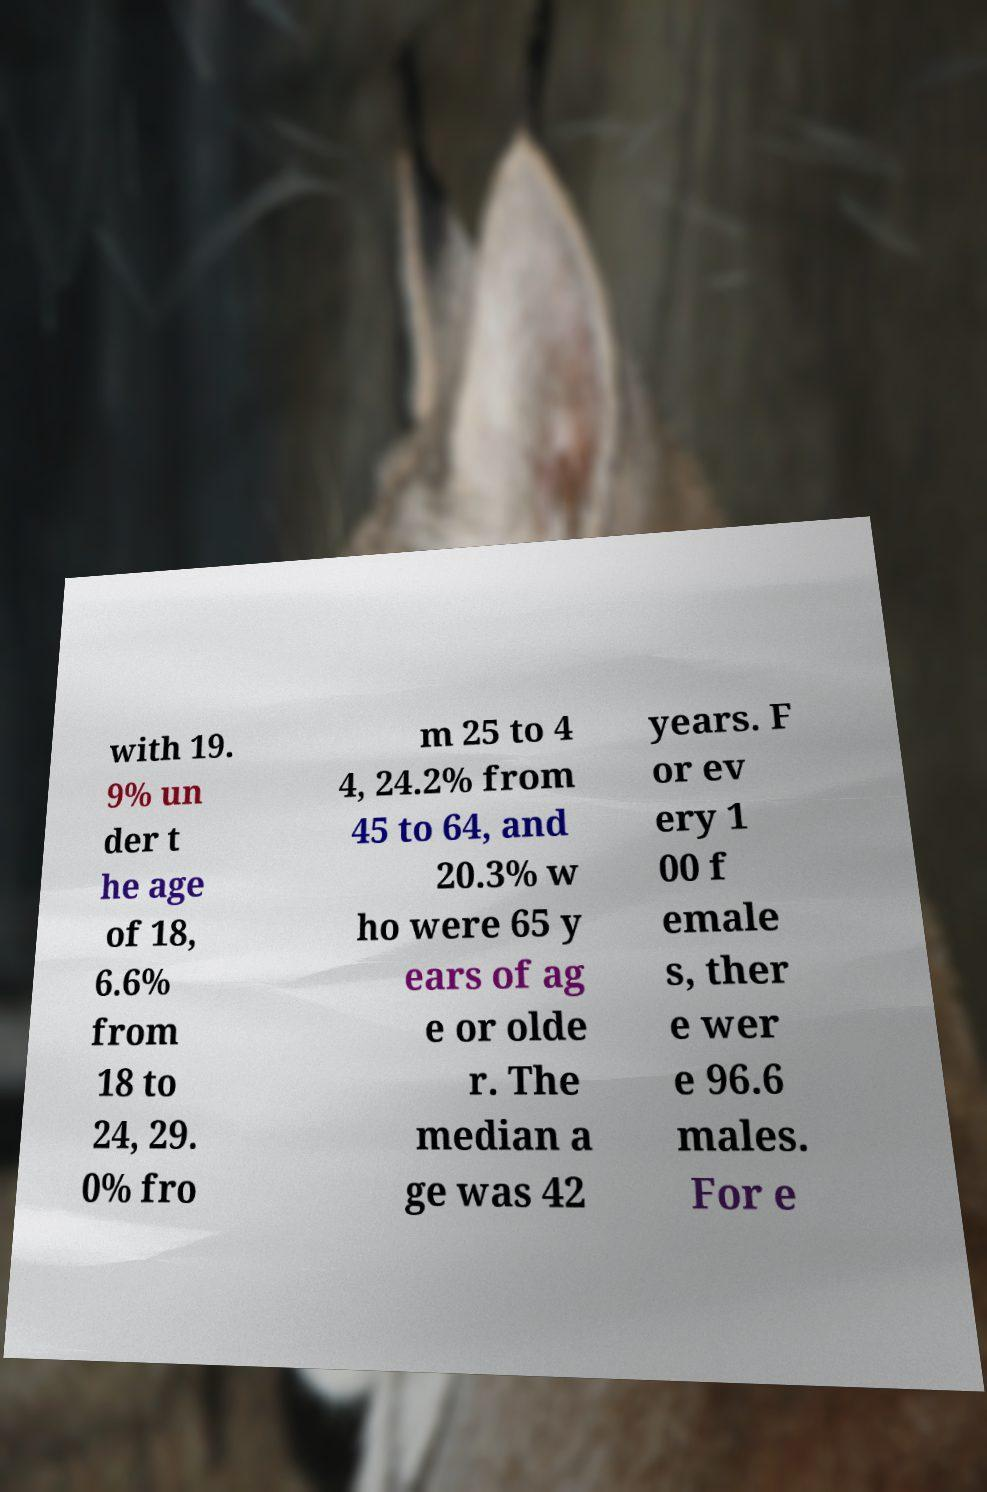I need the written content from this picture converted into text. Can you do that? with 19. 9% un der t he age of 18, 6.6% from 18 to 24, 29. 0% fro m 25 to 4 4, 24.2% from 45 to 64, and 20.3% w ho were 65 y ears of ag e or olde r. The median a ge was 42 years. F or ev ery 1 00 f emale s, ther e wer e 96.6 males. For e 